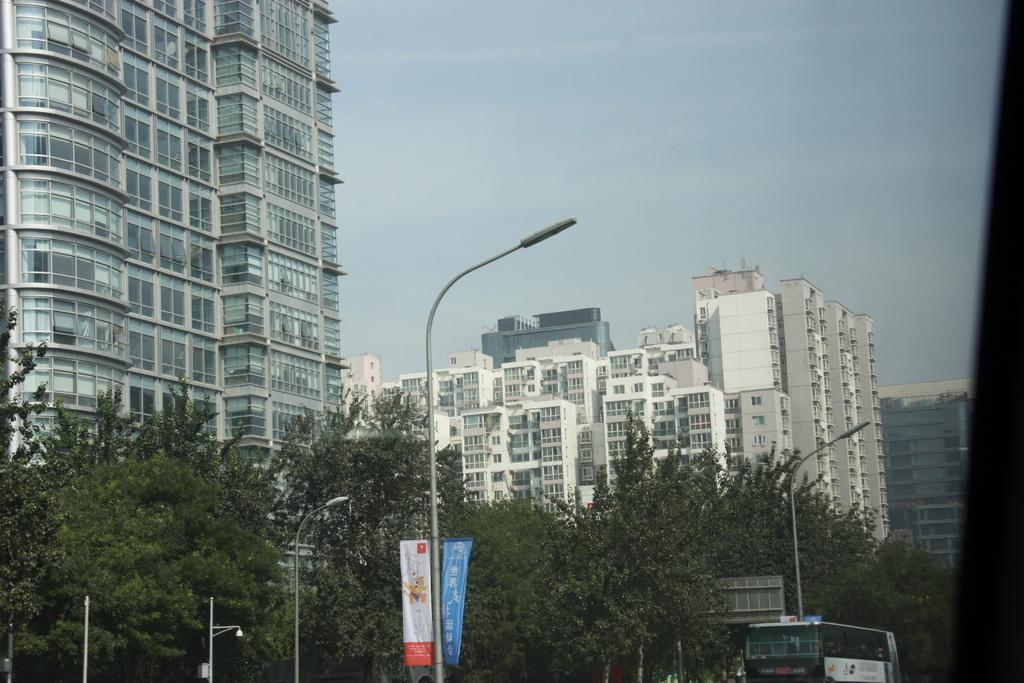What can be seen in the foreground area of the image? In the foreground area of the image, there are trees, poles, and a bus. What is located in the background of the image? In the background of the image, there are buildings and the sky is visible. Where are the vases placed in the image? There are no vases present in the image. What type of plants can be seen growing near the bus in the image? There are no plants visible near the bus in the image. 